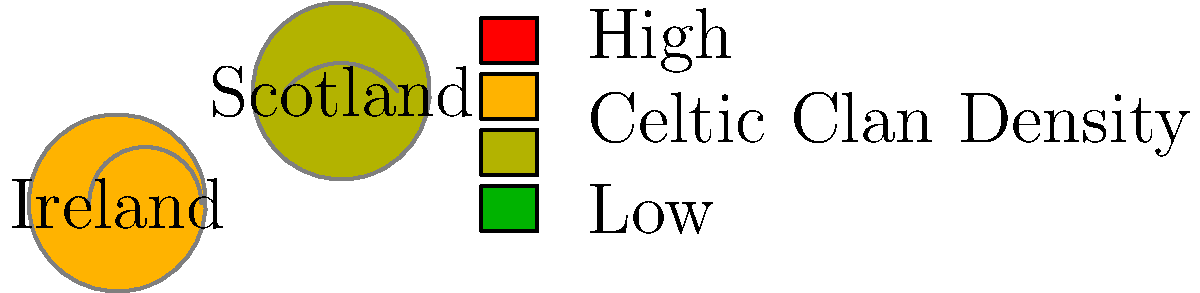Based on the heat map overlay on the topographical map of Ireland and Scotland, which region appears to have a higher concentration of Celtic clans, and what geographical features might have influenced this distribution? To answer this question, we need to analyze the heat map and topographical features presented in the image:

1. Heat map analysis:
   - Ireland is shown in orange, indicating a higher concentration of Celtic clans.
   - Scotland is depicted in yellow-green, suggesting a relatively lower concentration.

2. Topographical features:
   - Both Ireland and Scotland have topographical lines, representing elevation changes.
   - Ireland appears to have more pronounced topographical features, particularly in the central and western regions.

3. Geographical influence:
   - Ireland's higher concentration of Celtic clans could be attributed to:
     a) Its island geography, which may have isolated and preserved Celtic culture.
     b) The varied topography, providing natural defenses and distinct regional identities.

4. Historical context:
   - Ireland experienced less Roman influence compared to Scotland, potentially allowing for greater preservation of Celtic traditions.
   - The mountainous regions in both countries likely served as strongholds for Celtic clans, resisting external influences.

5. Comparative analysis:
   - While Scotland also has a significant Celtic heritage, the lower concentration shown might be due to:
     a) Greater external influences, including Roman, Anglo-Saxon, and Norse invasions.
     b) A larger landmass, potentially leading to more dispersed clan settlements.

Given these factors, Ireland appears to have a higher concentration of Celtic clans, likely influenced by its island geography, varied topography, and relative isolation from external influences compared to Scotland.
Answer: Ireland; island geography and varied topography 